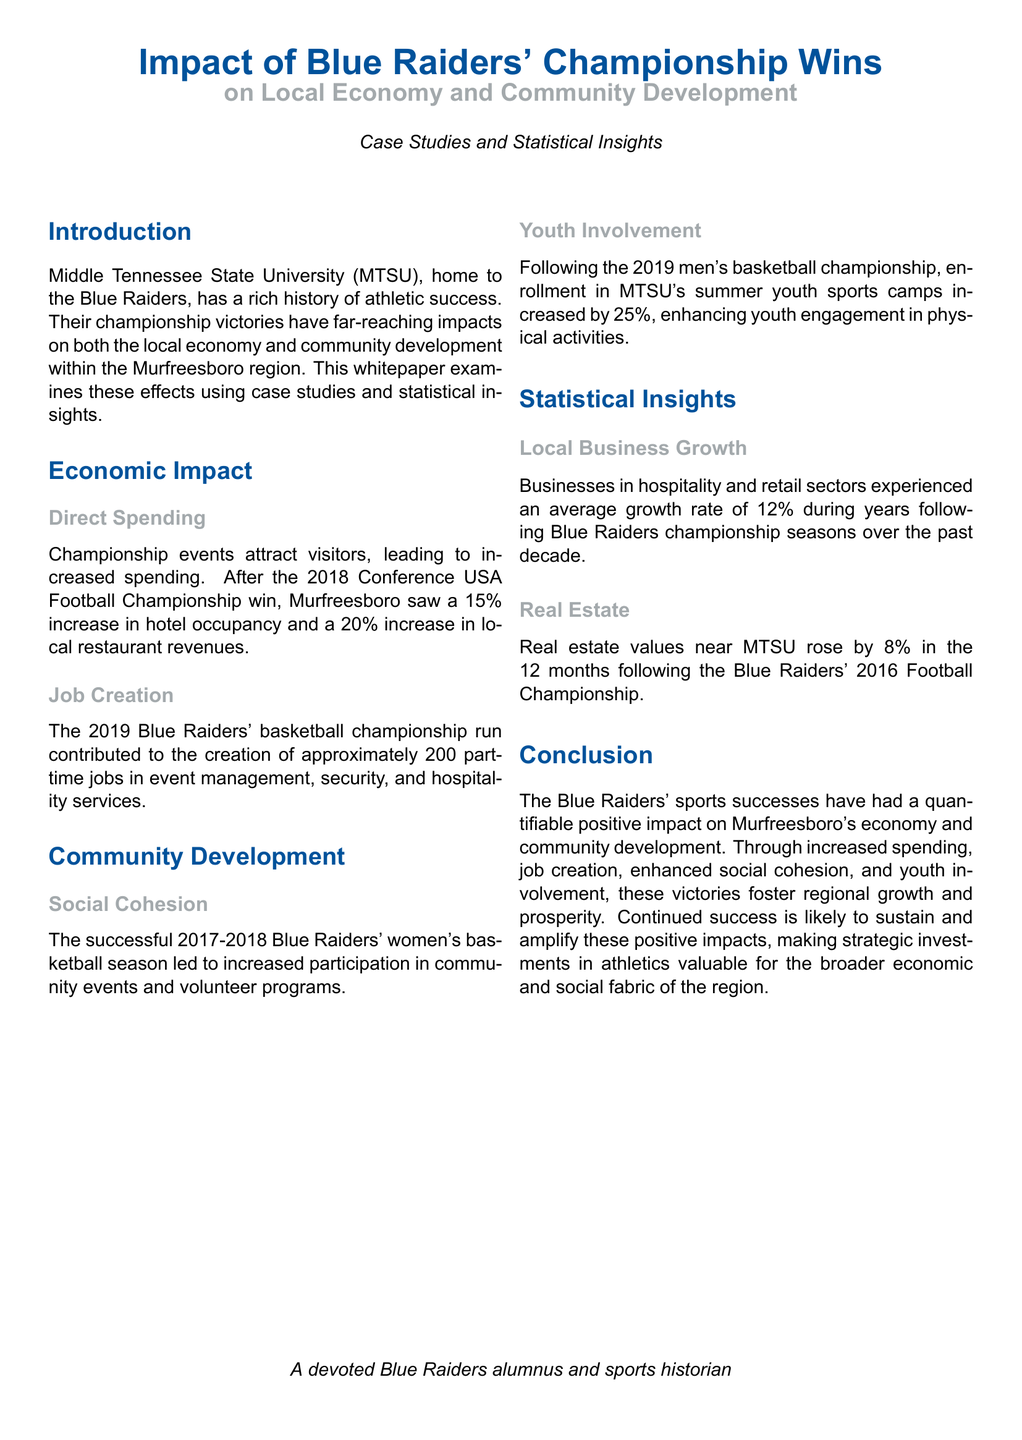What was the increase in hotel occupancy after the 2018 Championship win? The document states that after the 2018 Conference USA Football Championship win, Murfreesboro saw a 15% increase in hotel occupancy.
Answer: 15% How many part-time jobs were created during the 2019 basketball championship run? According to the whitepaper, the 2019 Blue Raiders' basketball championship run contributed to the creation of approximately 200 part-time jobs.
Answer: 200 What percentage increase in local restaurant revenues was reported after the 2018 win? The document mentions a 20% increase in local restaurant revenues following the 2018 Conference USA Football Championship win.
Answer: 20% When did the Blue Raiders' women's basketball season lead to increased community engagement? The successful season referred to in the document occurred in the 2017-2018 timeframe.
Answer: 2017-2018 What percentage increase in youth sports camp enrollment followed the 2019 men's basketball championship? The whitepaper indicates a 25% increase in enrollment in MTSU's summer youth sports camps after the 2019 championship.
Answer: 25% What was the average growth rate for local businesses during Blue Raiders championship seasons? The document states that businesses in the hospitality and retail sectors experienced an average growth rate of 12% during the years following championship seasons.
Answer: 12% By what percentage did real estate values rise near MTSU after the 2016 Football Championship? According to the whitepaper, real estate values near MTSU rose by 8% in the 12 months following the 2016 Football Championship.
Answer: 8% What is the primary focus of this whitepaper? The main focus of the whitepaper is on the impact of Blue Raiders' championship wins on local economy and community development.
Answer: Impact on local economy and community development What type of document is this? This is a whitepaper providing case studies and statistical insights about the Blue Raiders' impact on the community.
Answer: Whitepaper 